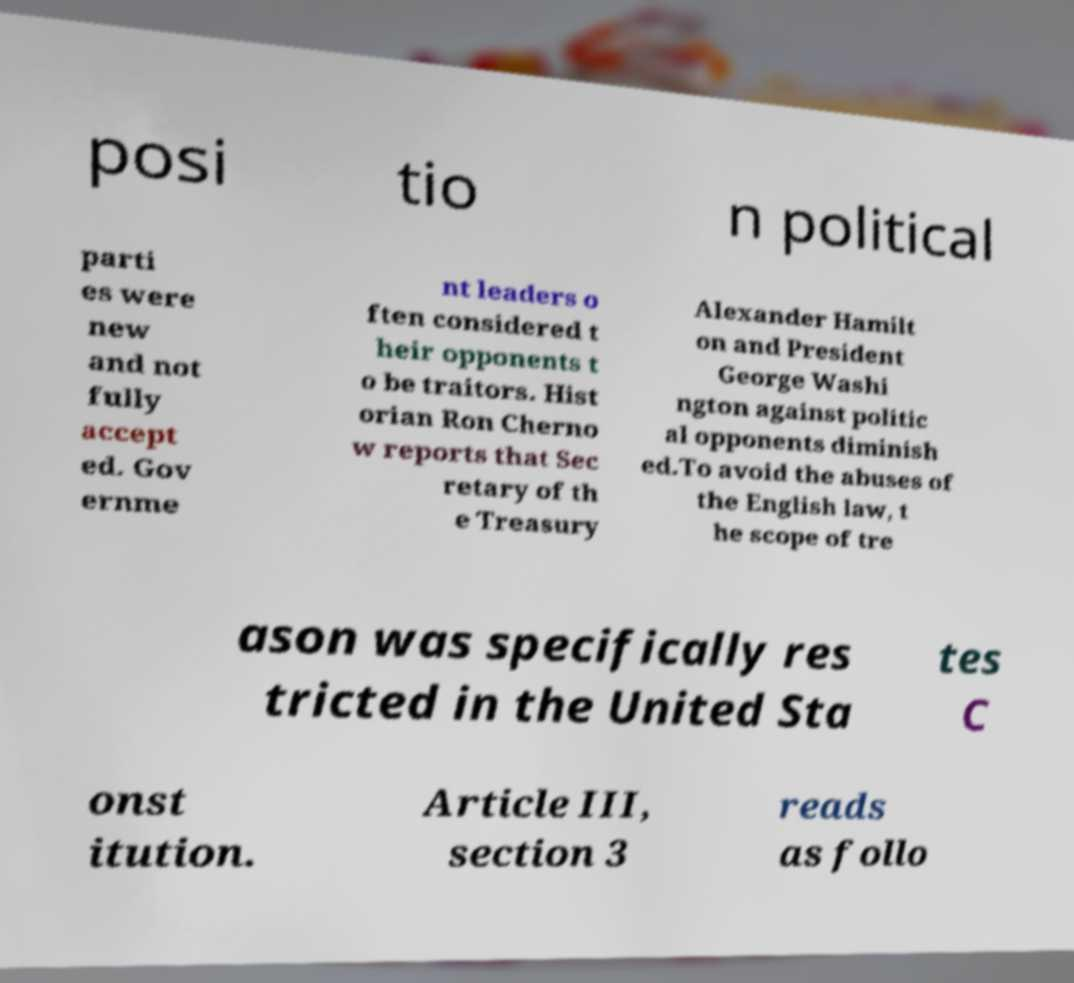Please identify and transcribe the text found in this image. posi tio n political parti es were new and not fully accept ed. Gov ernme nt leaders o ften considered t heir opponents t o be traitors. Hist orian Ron Cherno w reports that Sec retary of th e Treasury Alexander Hamilt on and President George Washi ngton against politic al opponents diminish ed.To avoid the abuses of the English law, t he scope of tre ason was specifically res tricted in the United Sta tes C onst itution. Article III, section 3 reads as follo 